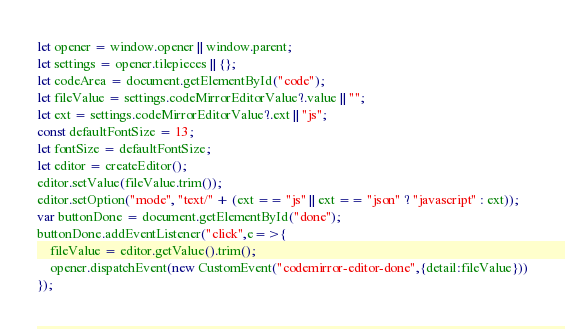Convert code to text. <code><loc_0><loc_0><loc_500><loc_500><_JavaScript_>let opener = window.opener || window.parent;
let settings = opener.tilepieces || {};
let codeArea = document.getElementById("code");
let fileValue = settings.codeMirrorEditorValue?.value || "";
let ext = settings.codeMirrorEditorValue?.ext || "js";
const defaultFontSize = 13;
let fontSize = defaultFontSize;
let editor = createEditor();
editor.setValue(fileValue.trim());
editor.setOption("mode", "text/" + (ext == "js" || ext == "json" ? "javascript" : ext));
var buttonDone = document.getElementById("done");
buttonDone.addEventListener("click",e=>{
    fileValue = editor.getValue().trim();
    opener.dispatchEvent(new CustomEvent("codemirror-editor-done",{detail:fileValue}))
});

</code> 